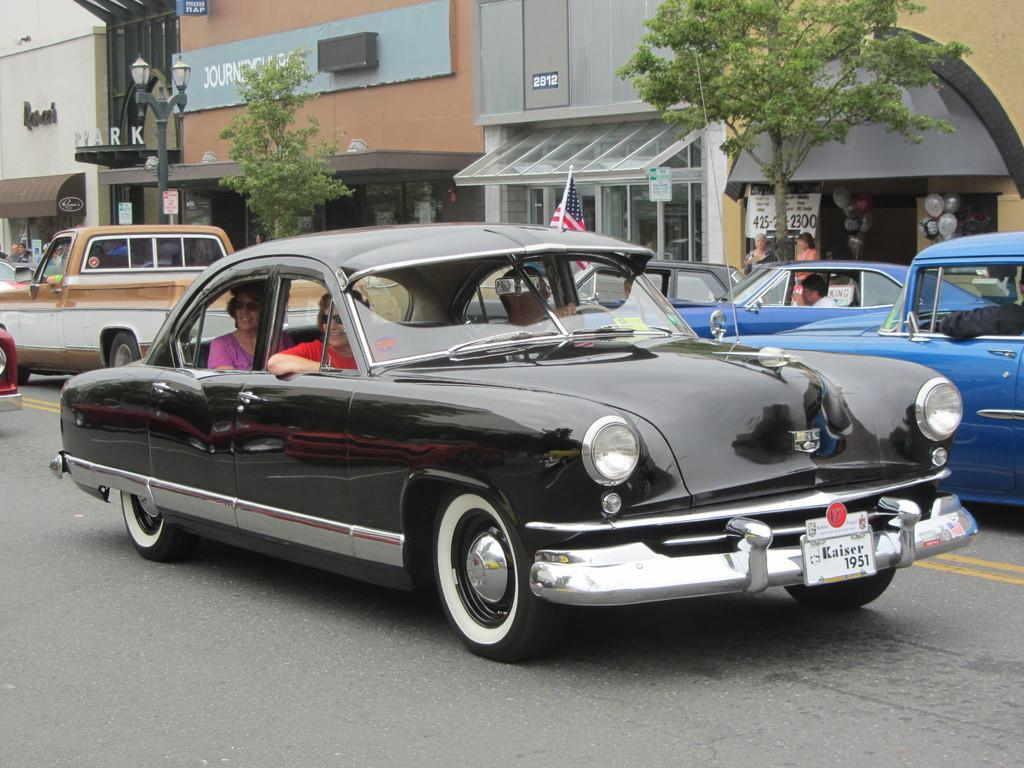What can be seen on the road in the image? There are vehicles on the road in the image. Who or what can be seen in the image besides the vehicles? There are people visible in the image. What can be seen in the distance in the image? There are buildings, trees, lights, and a flag in the background of the image. Can you describe the unspecified objects in the background of the image? Unfortunately, the facts provided do not specify the nature of these objects. What grade is the cloud teaching in the image? There is no cloud or teaching activity present in the image. What type of cloud can be seen in the image? There is no cloud visible in the image; it features vehicles on the road, people, and various elements in the background. 